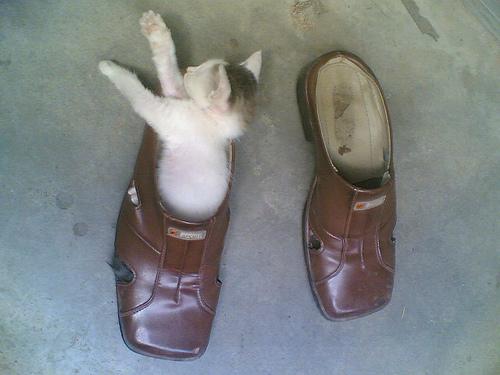Is the kitten asleep?
Give a very brief answer. Yes. What type of shoes are there?
Answer briefly. Loafers. What is the kitten doing in the shoe?
Be succinct. Sleeping. 